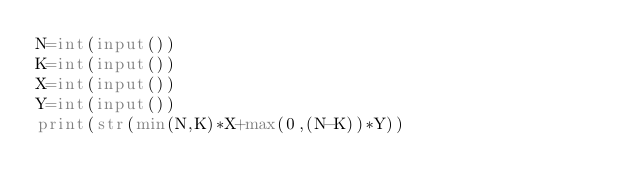Convert code to text. <code><loc_0><loc_0><loc_500><loc_500><_Python_>N=int(input())
K=int(input())
X=int(input())
Y=int(input())
print(str(min(N,K)*X+max(0,(N-K))*Y))</code> 